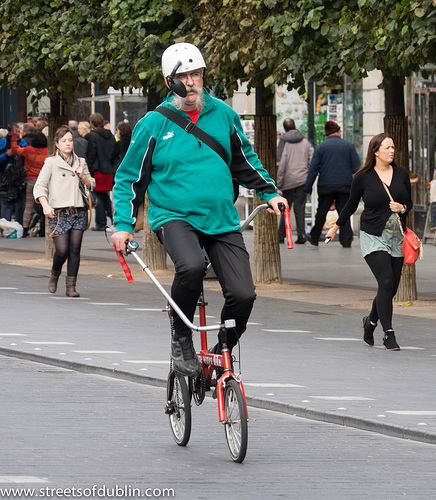<image>
Is the purse on the woman? Yes. Looking at the image, I can see the purse is positioned on top of the woman, with the woman providing support. 